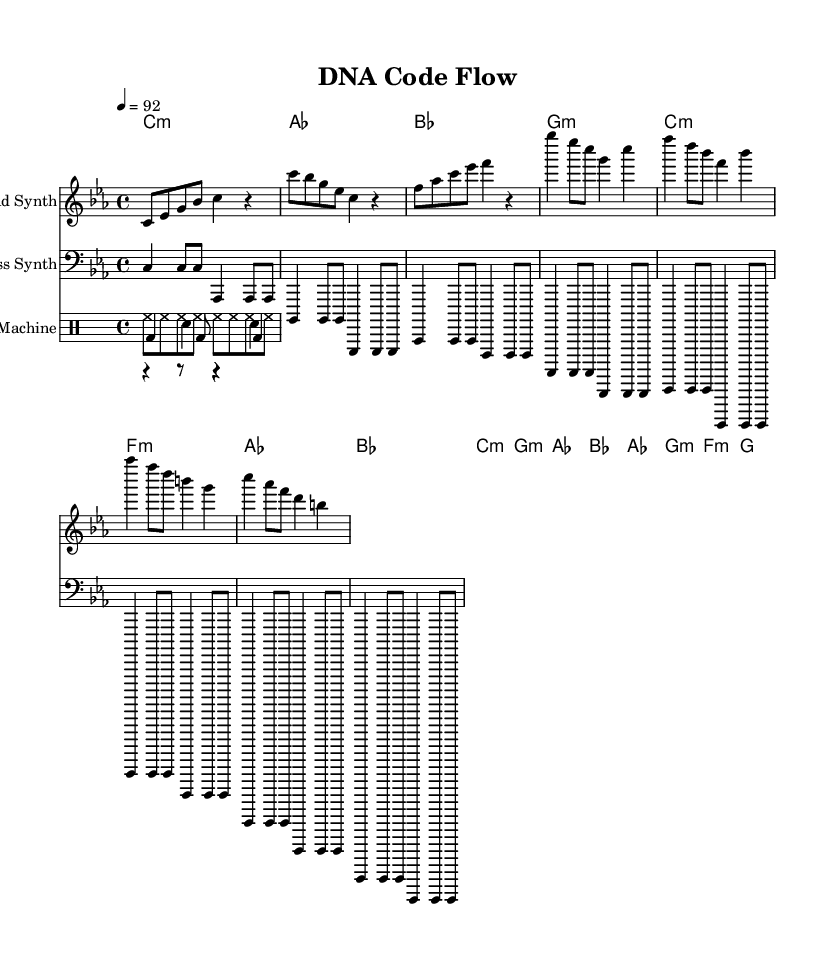What is the key signature of this music? The key signature shows C minor due to the presence of three flats: B flat, E flat, and A flat.
Answer: C minor What is the time signature of the piece? The time signature appears at the beginning of the score, indicated as 4/4, meaning there are four beats in each measure with a quarter note getting one beat.
Answer: 4/4 What is the tempo marking of this piece? The tempo marking is shown as 4 = 92, indicating that there should be 92 beats per minute.
Answer: 92 How many measures are in the verse section? By counting the measures in the verse section outlined in the sheet music, there are 4 measures present in the verse.
Answer: 4 What type of musical piece is "DNA Code Flow"? The structure and instrumentation suggest it is a rap piece, especially given its association with beats and rhythms typical for hip-hop music.
Answer: Rap Which instrument plays the lead melody? The lead melody is performed by a synthesizer, indicated by the staff labeled "Lead Synth" at the top of the score.
Answer: Lead Synth What indicates the use of a drum machine in the piece? The presence of the staff titled "Drum Machine" and the specific notations within the drum patterns indicate the use of a drum machine for this composition.
Answer: Drum Machine 